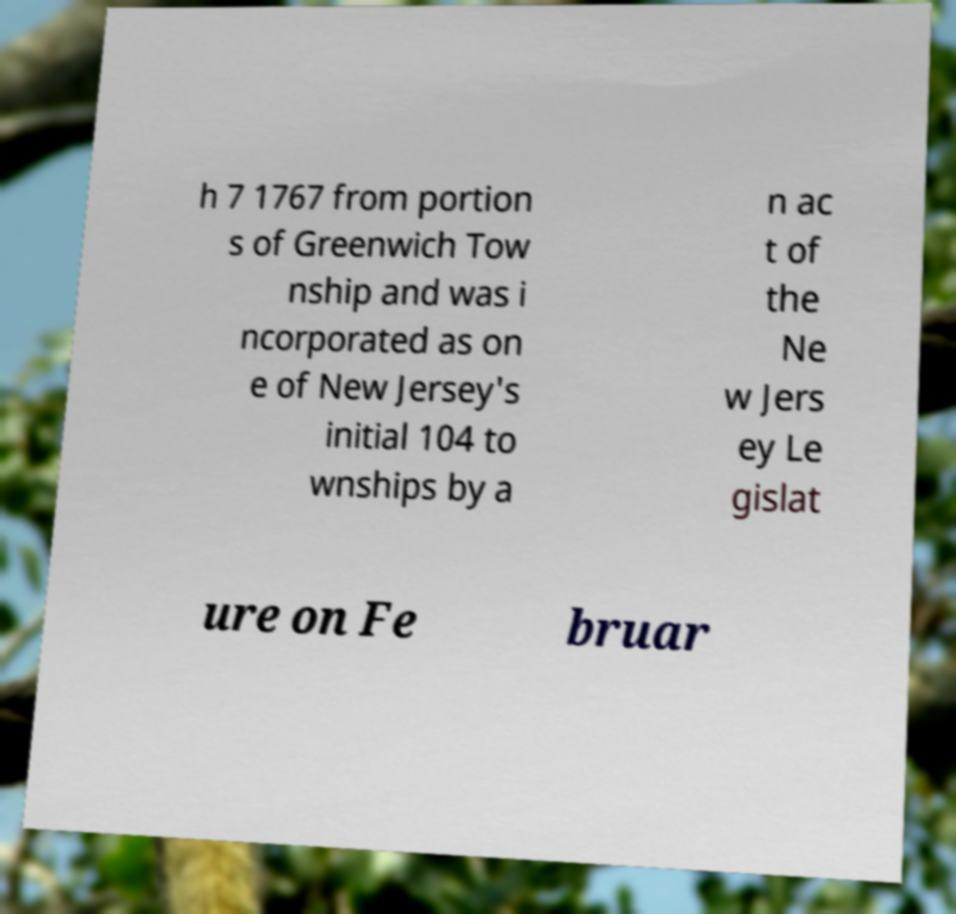Could you assist in decoding the text presented in this image and type it out clearly? h 7 1767 from portion s of Greenwich Tow nship and was i ncorporated as on e of New Jersey's initial 104 to wnships by a n ac t of the Ne w Jers ey Le gislat ure on Fe bruar 